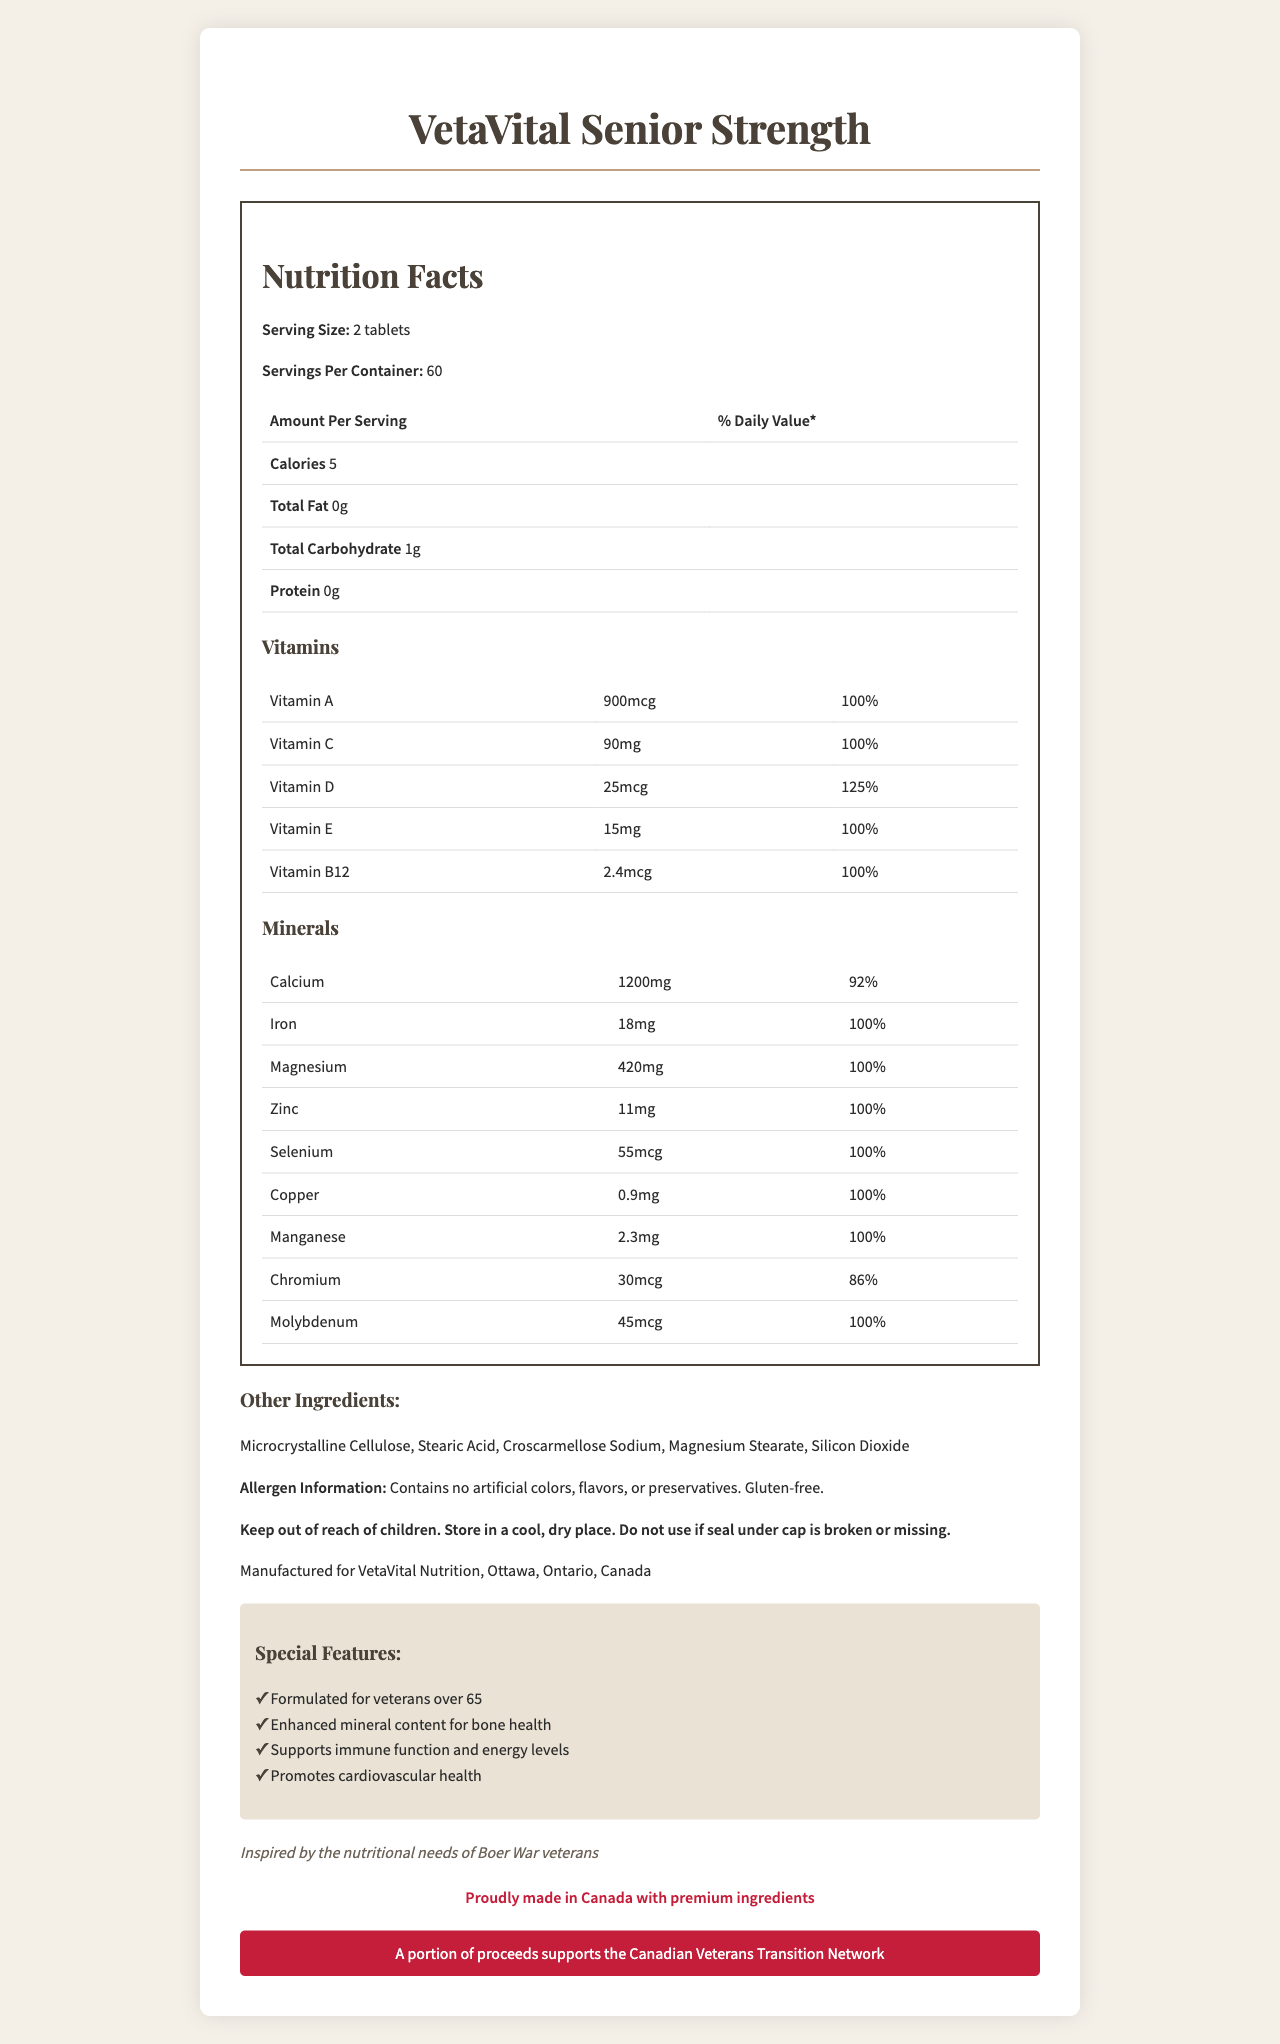what is the serving size of VetaVital Senior Strength? The serving size is clearly stated as "2 tablets" in the "Nutrition Facts" section of the document.
Answer: 2 tablets how many calories are there per serving? The document lists "Calories 5" under the "Amount Per Serving" header.
Answer: 5 what amount of Calcium is included per serving? The "Minerals" section specifies that each serving contains "1200mg" of Calcium.
Answer: 1200mg do the tablets contain any protein? The document states "Protein 0g" in the nutrition information, indicating that there is no protein per serving.
Answer: No how many servings are there in one container? The document clearly states "Servings Per Container: 60" in the nutrition facts section.
Answer: 60 which of the following vitamins is present in the highest daily value percentage? 
  A. Vitamin A
  B. Vitamin B12
  C. Vitamin D
  D. Vitamin C Vitamin D has the highest daily value percentage at 125%.
Answer: C which mineral has the lowest daily value percentage? 
  1. Calcium
  2. Iron
  3. Chromium
  4. Magnesium Chromium has the lowest daily value percentage at 86%.
Answer: Chromium does the document state whether the product contains any artificial colors or flavors? The allergen information clearly states "Contains no artificial colors, flavors, or preservatives."
Answer: No is the product gluten-free? The allergen information in the document states "Gluten-free."
Answer: Yes summarize the main features and purpose of VetaVital Senior Strength The document provides nutrition facts, ingredients, allergen information, and special features. It emphasizes minerals like Calcium and Magnesium, mentions historical context inspired by Boer War veterans, and highlights veteran support.
Answer: The document describes VetaVital Senior Strength as a vitamin supplement designed for aging veterans over 65, emphasizing enhanced mineral content for bone health, immune function, energy levels, and cardiovascular health. It is made in Canada and supports the Canadian Veterans Transition Network. what impact does Vitamin C have on the daily diet according to this product? The document indicates that each serving contains 90mg of Vitamin C, which equals 100% of the daily value.
Answer: 100% of the daily value how much Manganese is included per serving? The minerals section specifies that each serving includes "2.3mg" of Manganese, equal to 100% daily value.
Answer: 2.3mg who manufactures VetaVital Senior Strength? The document states that the product is "Manufactured for VetaVital Nutrition, Ottawa, Ontario, Canada."
Answer: VetaVital Nutrition, Ottawa, Ontario, Canada does the product support any veteran organizations? The document states that "A portion of proceeds supports the Canadian Veterans Transition Network."
Answer: Yes is there information on how the tablets should be stored? The document includes a warning statement: "Store in a cool, dry place."
Answer: Yes how many special features does VetaVital Senior Strength have? The document lists four special features: formulated for veterans over 65, enhanced mineral content, supports immune function and energy levels, promotes cardiovascular health.
Answer: 4 what Omega fatty acids does the product include? The document does not mention Omega fatty acids or provide any information related to them.
Answer: Cannot be determined 